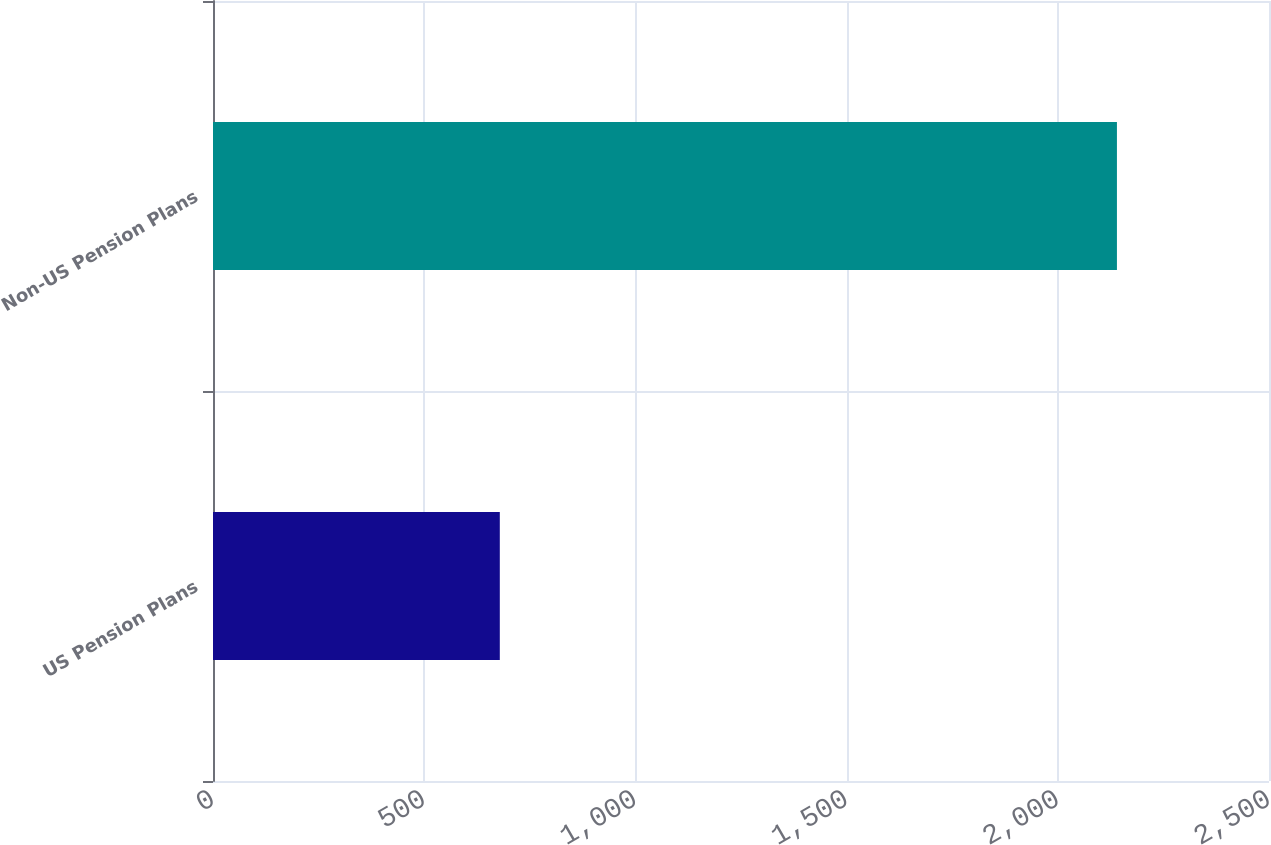Convert chart. <chart><loc_0><loc_0><loc_500><loc_500><bar_chart><fcel>US Pension Plans<fcel>Non-US Pension Plans<nl><fcel>679<fcel>2140<nl></chart> 